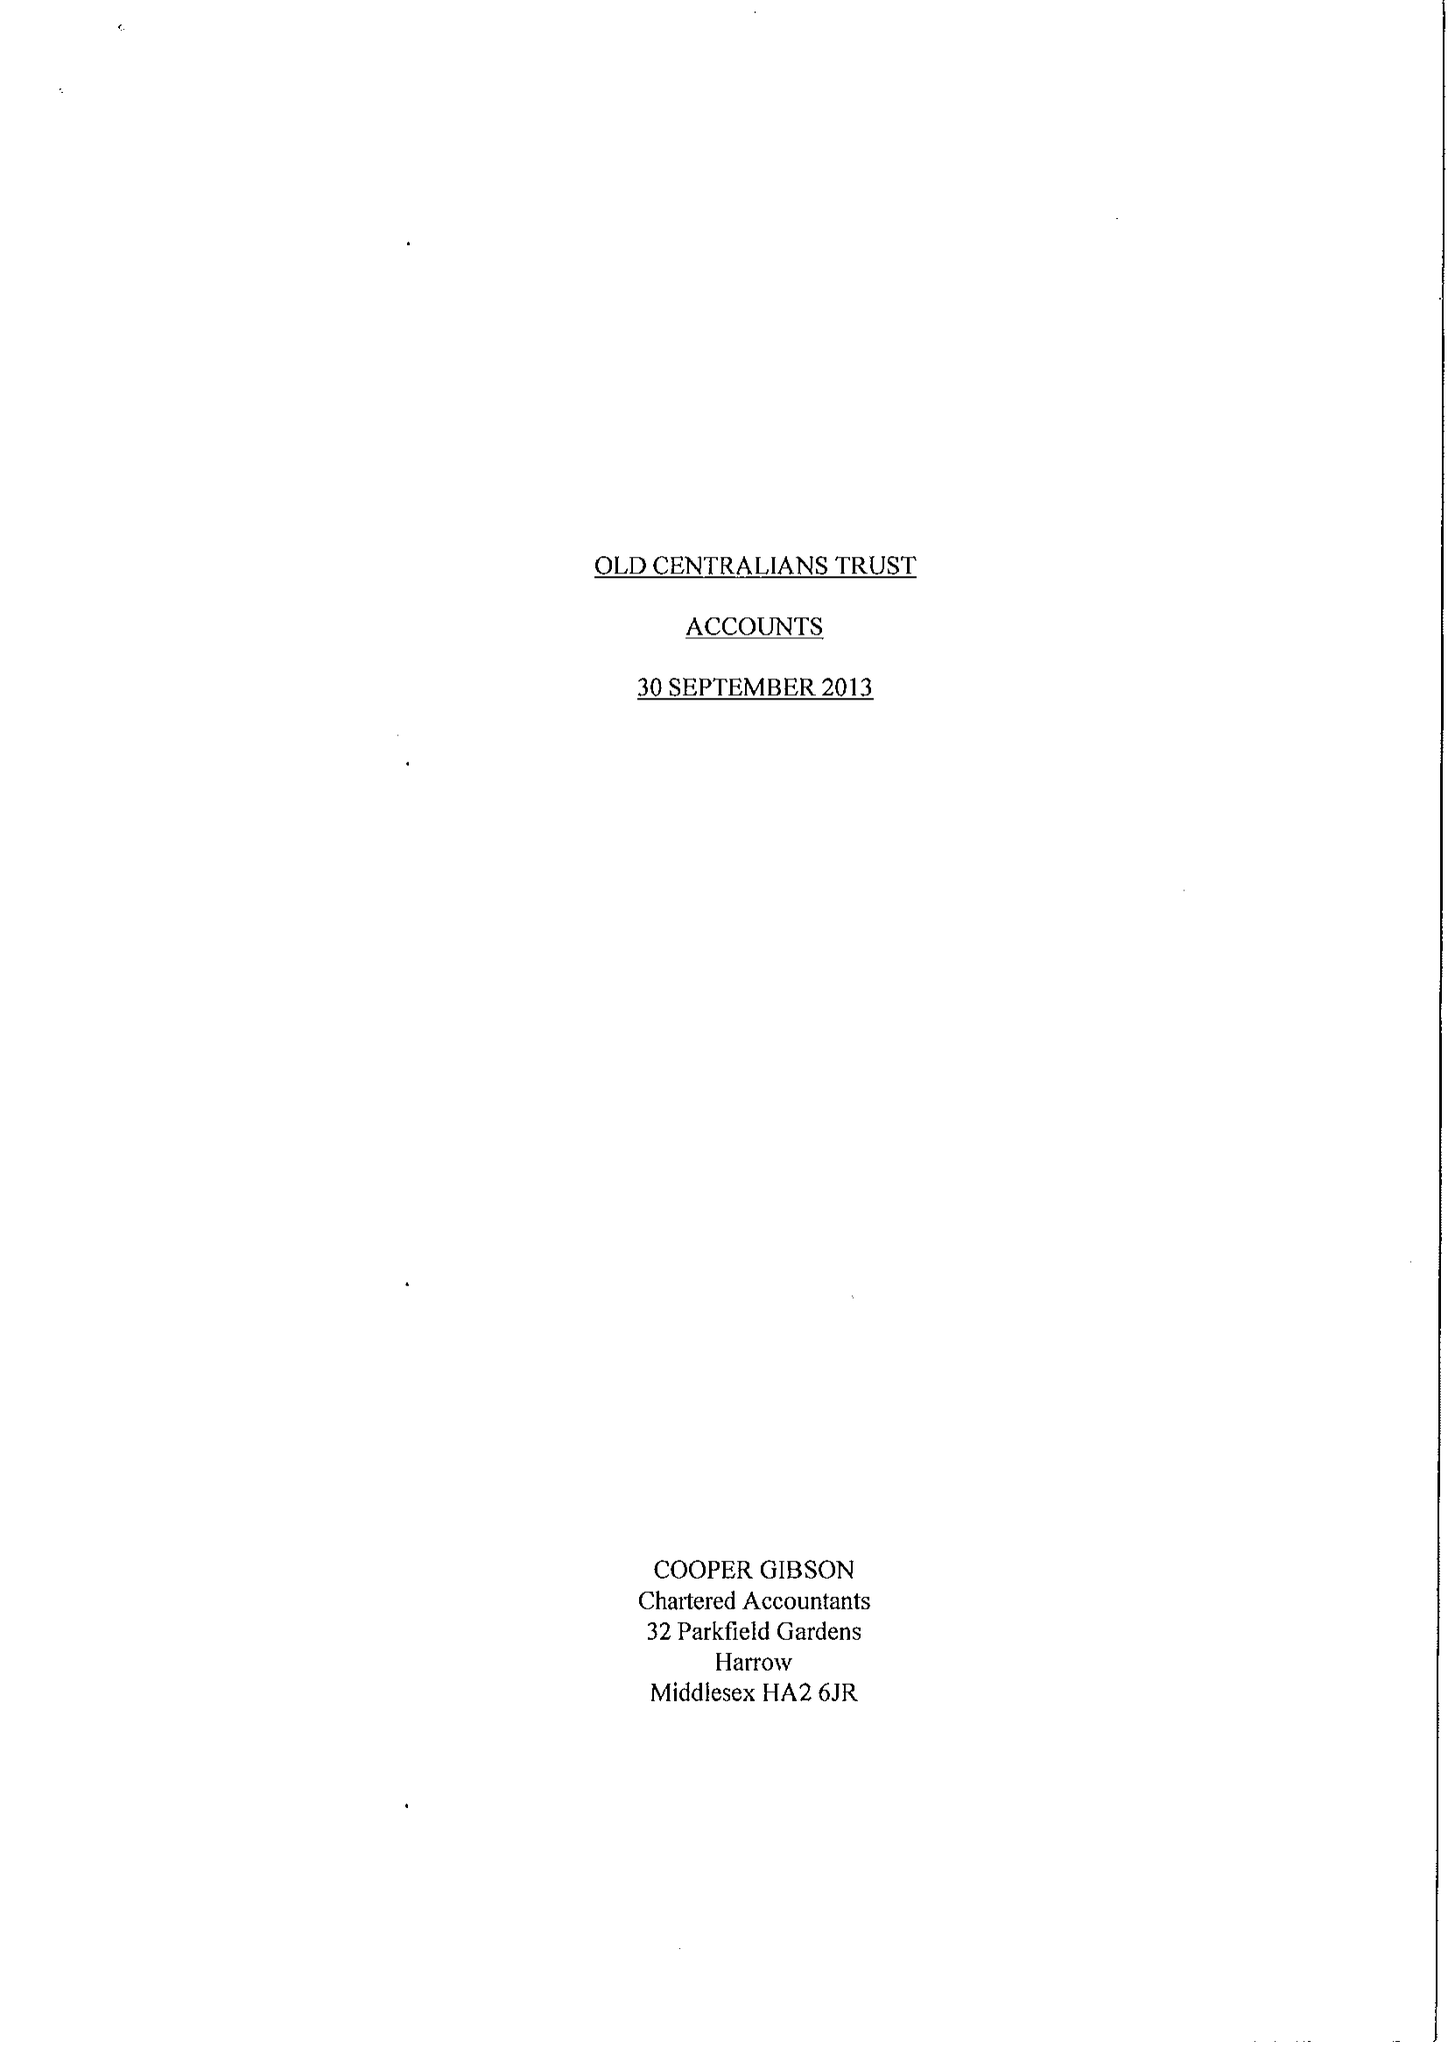What is the value for the income_annually_in_british_pounds?
Answer the question using a single word or phrase. 69330.00 